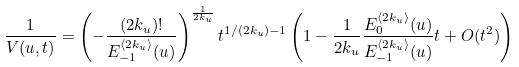<formula> <loc_0><loc_0><loc_500><loc_500>\frac { 1 } { V ( u , t ) } = \left ( - \frac { ( 2 k _ { u } ) ! } { E _ { - 1 } ^ { \langle 2 k _ { u } \rangle } ( u ) } \right ) ^ { \frac { 1 } { 2 k _ { u } } } t ^ { 1 / ( 2 k _ { u } ) - 1 } \left ( 1 - \frac { 1 } { 2 k _ { u } } \frac { E _ { 0 } ^ { \langle 2 k _ { u } \rangle } ( u ) } { E _ { - 1 } ^ { \langle 2 k _ { u } \rangle } ( u ) } t + O ( t ^ { 2 } ) \right )</formula> 